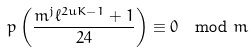<formula> <loc_0><loc_0><loc_500><loc_500>p \left ( \frac { m ^ { j } \ell ^ { 2 u K - 1 } + 1 } { 2 4 } \right ) \equiv 0 \mod m</formula> 